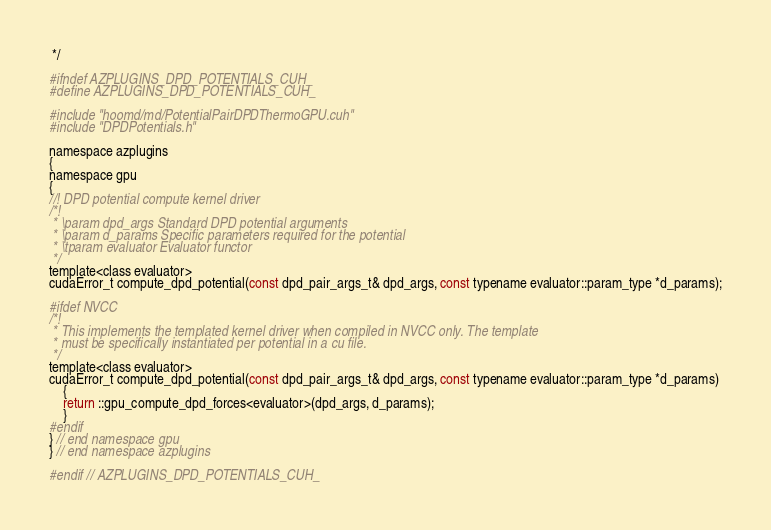<code> <loc_0><loc_0><loc_500><loc_500><_Cuda_> */

#ifndef AZPLUGINS_DPD_POTENTIALS_CUH_
#define AZPLUGINS_DPD_POTENTIALS_CUH_

#include "hoomd/md/PotentialPairDPDThermoGPU.cuh"
#include "DPDPotentials.h"

namespace azplugins
{
namespace gpu
{
//! DPD potential compute kernel driver
/*!
 * \param dpd_args Standard DPD potential arguments
 * \param d_params Specific parameters required for the potential
 * \tparam evaluator Evaluator functor
 */
template<class evaluator>
cudaError_t compute_dpd_potential(const dpd_pair_args_t& dpd_args, const typename evaluator::param_type *d_params);

#ifdef NVCC
/*!
 * This implements the templated kernel driver when compiled in NVCC only. The template
 * must be specifically instantiated per potential in a cu file.
 */
template<class evaluator>
cudaError_t compute_dpd_potential(const dpd_pair_args_t& dpd_args, const typename evaluator::param_type *d_params)
    {
    return ::gpu_compute_dpd_forces<evaluator>(dpd_args, d_params);
    }
#endif
} // end namespace gpu
} // end namespace azplugins

#endif // AZPLUGINS_DPD_POTENTIALS_CUH_
</code> 